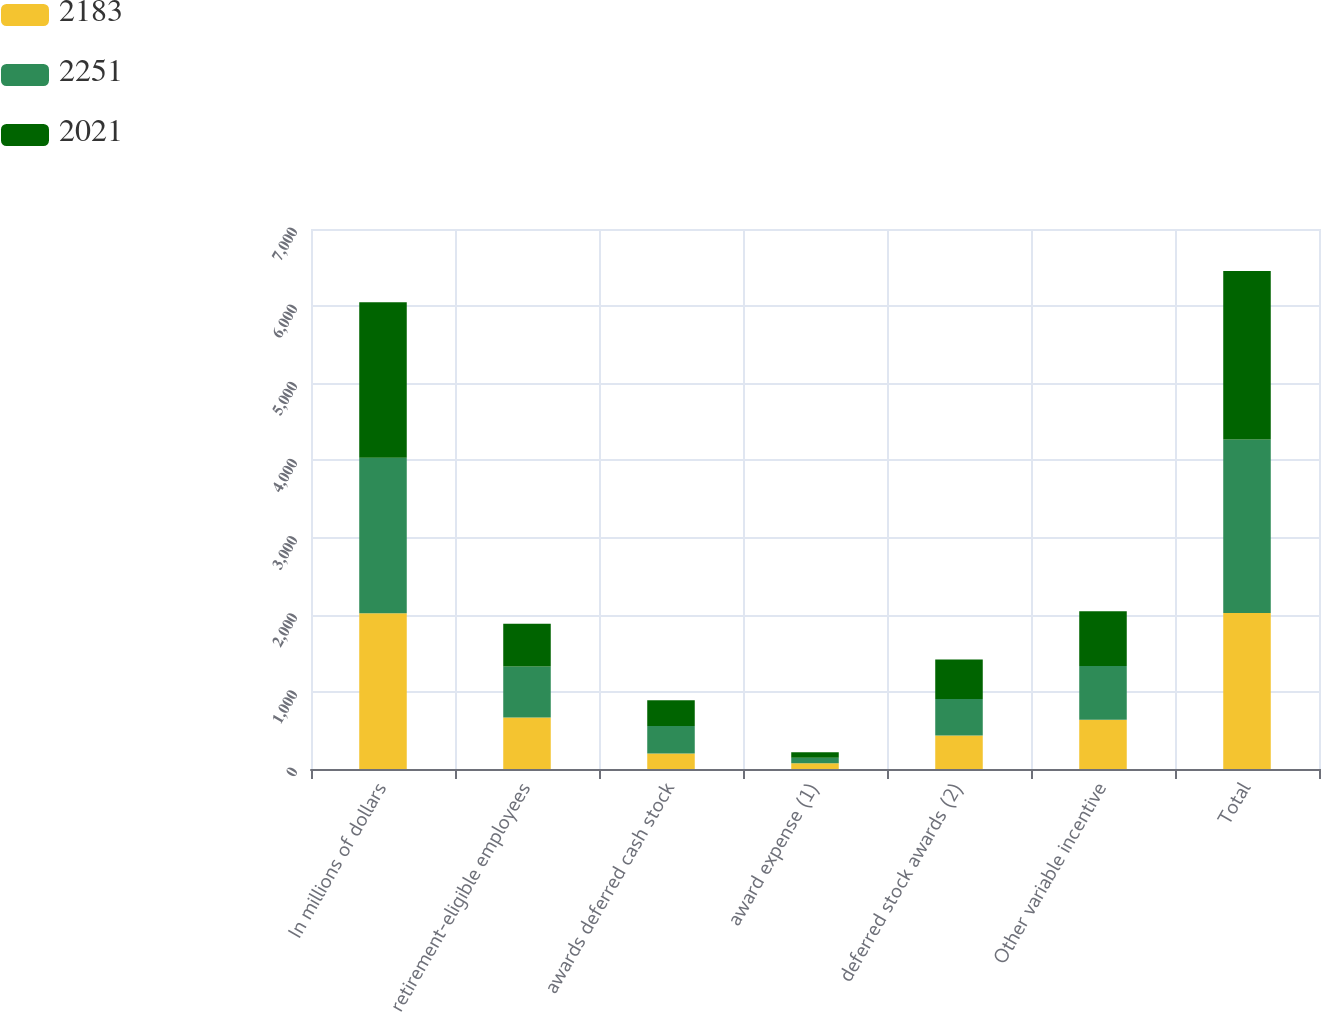<chart> <loc_0><loc_0><loc_500><loc_500><stacked_bar_chart><ecel><fcel>In millions of dollars<fcel>retirement-eligible employees<fcel>awards deferred cash stock<fcel>award expense (1)<fcel>deferred stock awards (2)<fcel>Other variable incentive<fcel>Total<nl><fcel>2183<fcel>2018<fcel>669<fcel>202<fcel>75<fcel>435<fcel>640<fcel>2021<nl><fcel>2251<fcel>2017<fcel>659<fcel>354<fcel>70<fcel>474<fcel>694<fcel>2251<nl><fcel>2021<fcel>2016<fcel>555<fcel>336<fcel>73<fcel>509<fcel>710<fcel>2183<nl></chart> 